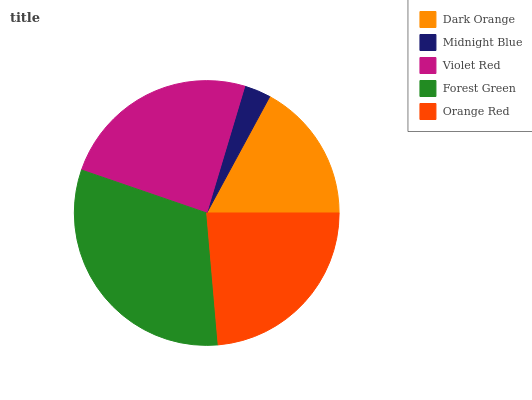Is Midnight Blue the minimum?
Answer yes or no. Yes. Is Forest Green the maximum?
Answer yes or no. Yes. Is Violet Red the minimum?
Answer yes or no. No. Is Violet Red the maximum?
Answer yes or no. No. Is Violet Red greater than Midnight Blue?
Answer yes or no. Yes. Is Midnight Blue less than Violet Red?
Answer yes or no. Yes. Is Midnight Blue greater than Violet Red?
Answer yes or no. No. Is Violet Red less than Midnight Blue?
Answer yes or no. No. Is Orange Red the high median?
Answer yes or no. Yes. Is Orange Red the low median?
Answer yes or no. Yes. Is Violet Red the high median?
Answer yes or no. No. Is Forest Green the low median?
Answer yes or no. No. 